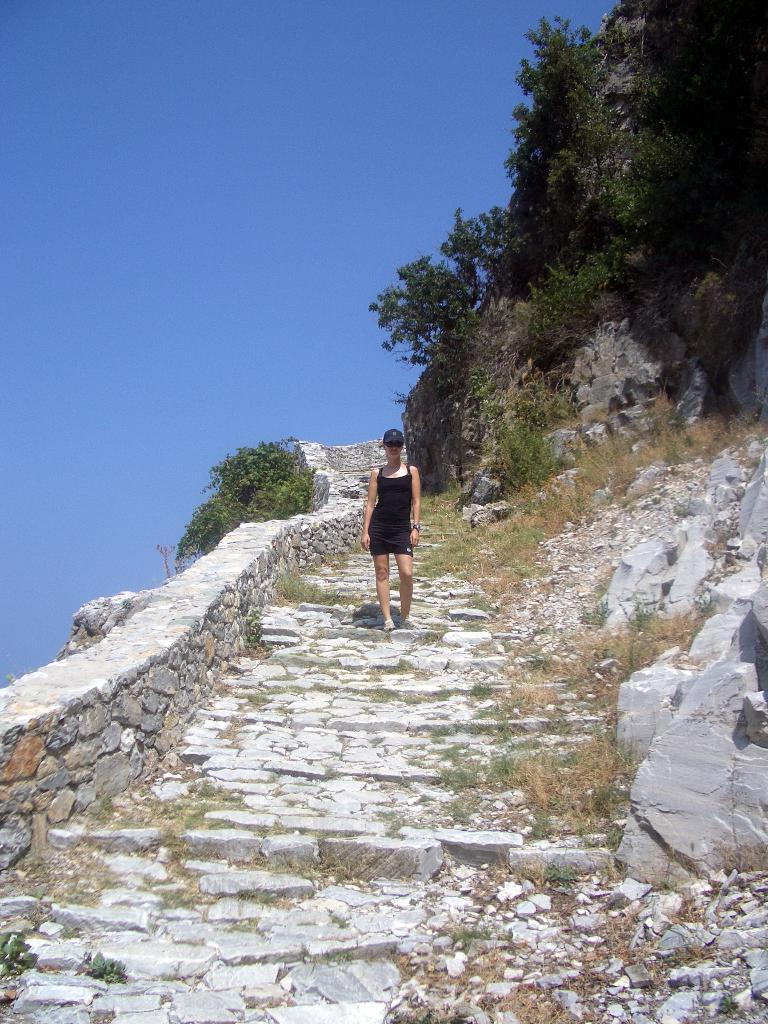Who is present in the image? There is a woman in the image. What is the woman wearing? The woman is wearing a black dress. What is the woman doing in the image? The woman is walking on the steps. What can be seen on either side of the steps? There are trees on either side of the steps. What is located on the left side of the steps? There is a fence on the left side of the steps. What is visible above the steps? The sky is visible above the steps. What type of hall can be seen in the image? There is no hall present in the image; it features a woman walking on steps surrounded by trees and a fence. What kind of quiver is the woman carrying in the image? There is no quiver present in the image; the woman is simply walking on the steps in a black dress. 